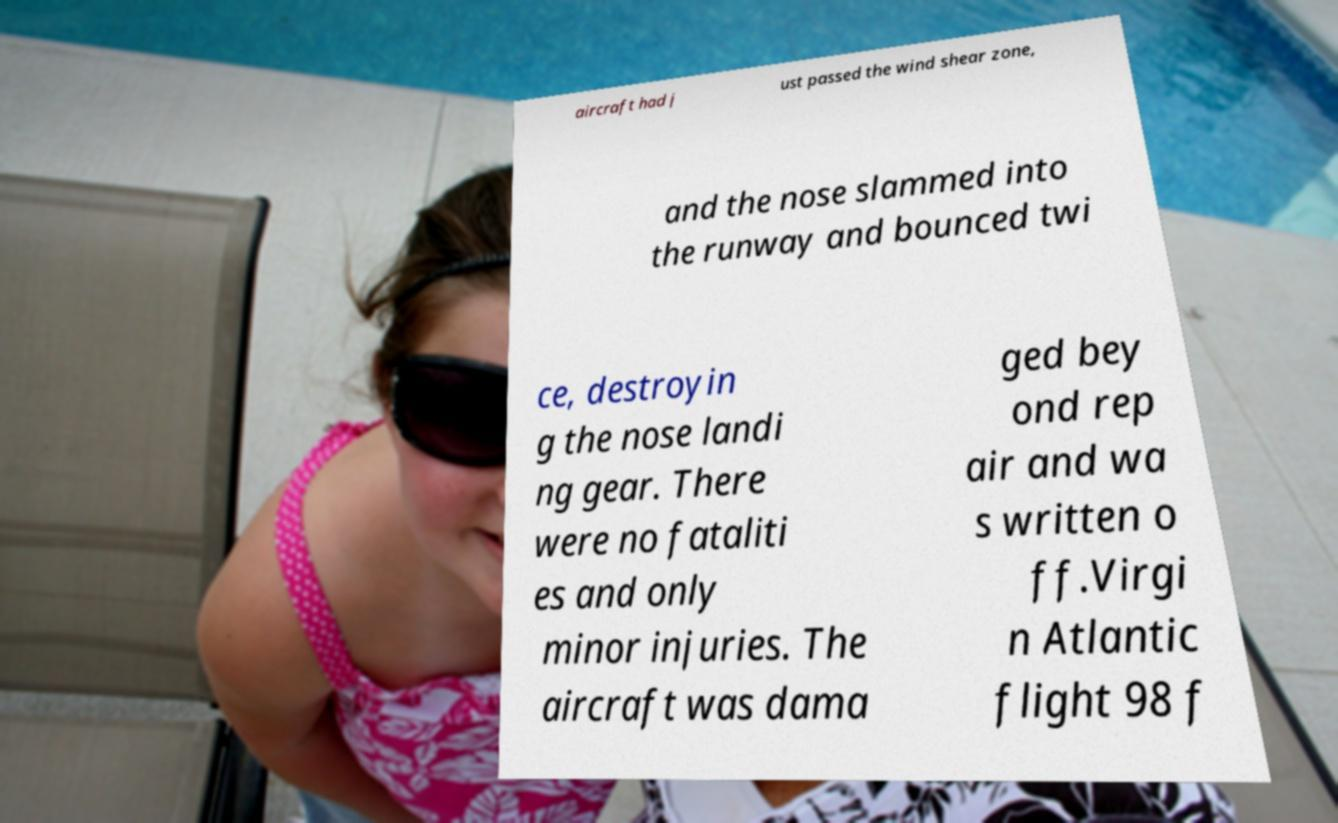Please identify and transcribe the text found in this image. aircraft had j ust passed the wind shear zone, and the nose slammed into the runway and bounced twi ce, destroyin g the nose landi ng gear. There were no fataliti es and only minor injuries. The aircraft was dama ged bey ond rep air and wa s written o ff.Virgi n Atlantic flight 98 f 